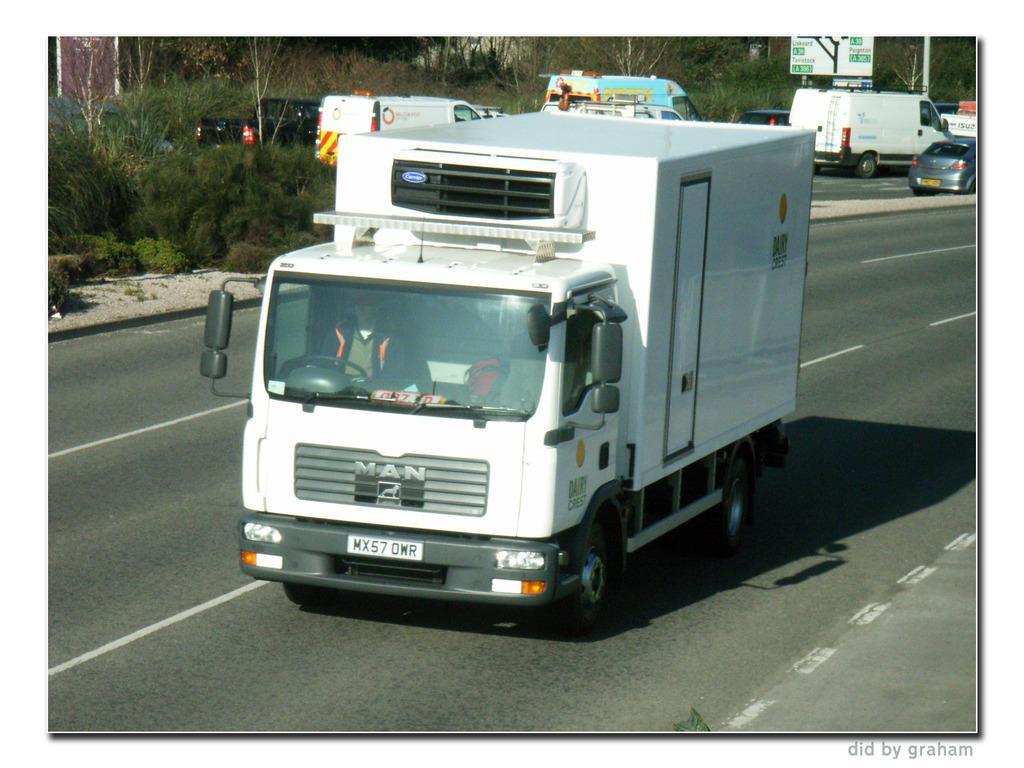Can you describe this image briefly? In the foreground of the image we can see a person sitting in a vehicle placed on the ground. In the background, we can see group of vehicles parked on the road, a group of trees, sign board with the text and in the bottom we can see some text. 